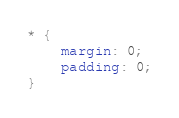Convert code to text. <code><loc_0><loc_0><loc_500><loc_500><_CSS_>* {
	margin: 0;
	padding: 0;
}

</code> 